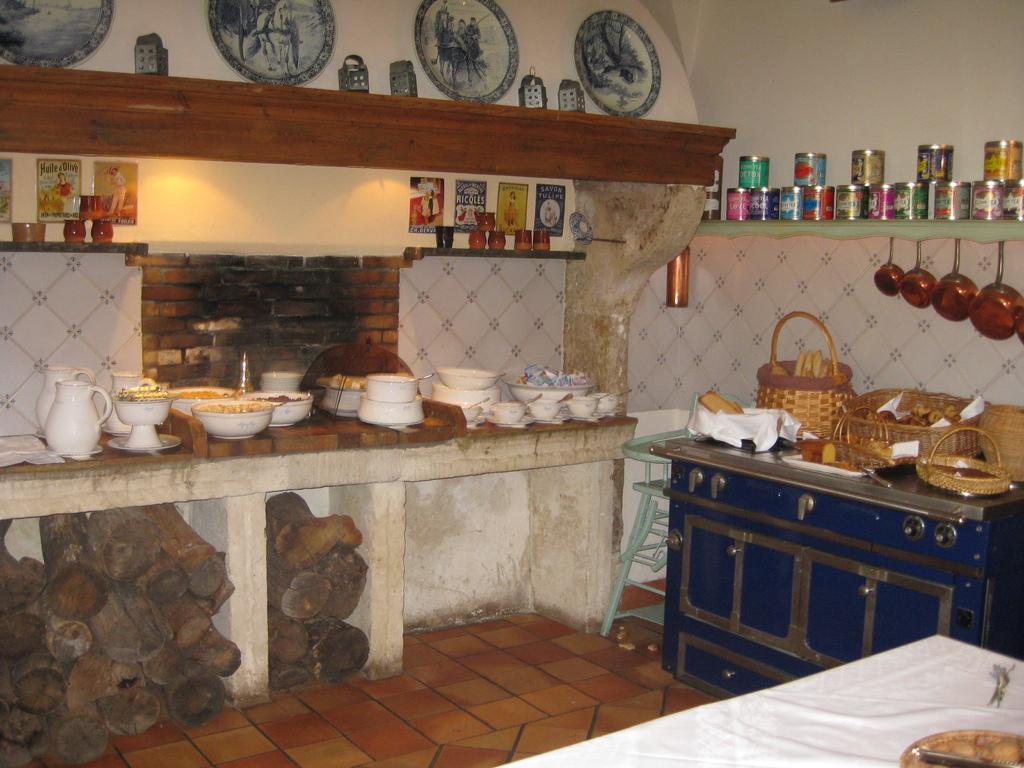In one or two sentences, can you explain what this image depicts? IN this image we can see a inside view of a kitchen. To the right side we can see a cupboard on which different brackets are placed. On top right corner of the image we see different containers. to the left side of the image we can see several bowls placed on the countertop. In the bottom we can see several wood logs placed on the floor. In the background we can see plates place on the wall. 